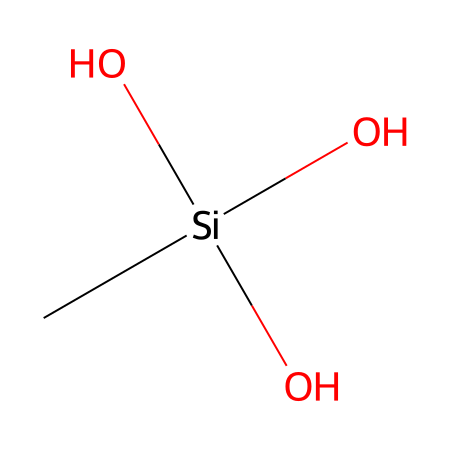What is the central atom in this silane compound? The central atom in silane compounds is typically silicon, which is represented as [Si] in the SMILES notation.
Answer: silicon How many oxygen atoms are present in this compound? By examining the SMILES representation, there are three oxygen atoms attached to the silicon atom, indicated by (O)(O)(O).
Answer: three What functional groups are present in this silane structure? The structure has hydroxyl (-OH) groups due to the presence of three oxygen atoms, each bond to the silicon.
Answer: hydroxyl groups Is this silane compound likely to be polar or nonpolar? The presence of hydroxyl groups contributes to a polar character because of their electronegativity and ability to form hydrogen bonds.
Answer: polar What is the likely role of this silane in soundproofing materials? Silanes with hydroxyl groups can enhance adhesion properties in soundproofing materials, improving the binding between materials, leading to better sound insulation.
Answer: adhesion properties How does the number of substituents on silicon influence the properties of the silane? More hydroxyl substituents on silicon generally increase polarity and reactivity, affecting characteristics like solubility in water and bonding with materials in soundproofing.
Answer: increases polarity and reactivity What aspect of this silane structure makes it suitable for soundproofing applications? The presence of multiple hydroxyl groups can enhance its ability to form strong bonds with other materials, improving the effectiveness of soundproofing.
Answer: strong bonding capability 